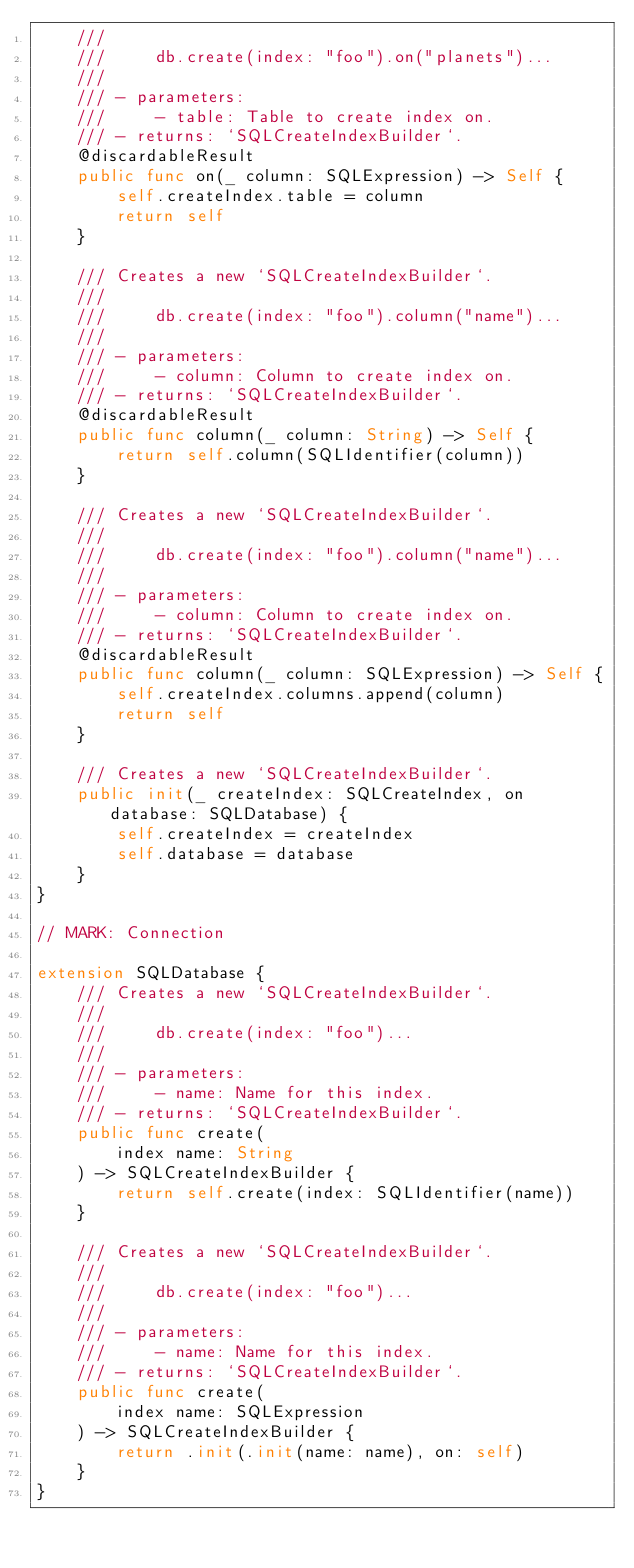<code> <loc_0><loc_0><loc_500><loc_500><_Swift_>    ///
    ///     db.create(index: "foo").on("planets")...
    ///
    /// - parameters:
    ///     - table: Table to create index on.
    /// - returns: `SQLCreateIndexBuilder`.
    @discardableResult
    public func on(_ column: SQLExpression) -> Self {
        self.createIndex.table = column
        return self
    }
    
    /// Creates a new `SQLCreateIndexBuilder`.
    ///
    ///     db.create(index: "foo").column("name")...
    ///
    /// - parameters:
    ///     - column: Column to create index on.
    /// - returns: `SQLCreateIndexBuilder`.
    @discardableResult
    public func column(_ column: String) -> Self {
        return self.column(SQLIdentifier(column))
    }
    
    /// Creates a new `SQLCreateIndexBuilder`.
    ///
    ///     db.create(index: "foo").column("name")...
    ///
    /// - parameters:
    ///     - column: Column to create index on.
    /// - returns: `SQLCreateIndexBuilder`.
    @discardableResult
    public func column(_ column: SQLExpression) -> Self {
        self.createIndex.columns.append(column)
        return self
    }
    
    /// Creates a new `SQLCreateIndexBuilder`.
    public init(_ createIndex: SQLCreateIndex, on database: SQLDatabase) {
        self.createIndex = createIndex
        self.database = database
    }
}

// MARK: Connection

extension SQLDatabase {
    /// Creates a new `SQLCreateIndexBuilder`.
    ///
    ///     db.create(index: "foo")...
    ///
    /// - parameters:
    ///     - name: Name for this index.
    /// - returns: `SQLCreateIndexBuilder`.
    public func create(
        index name: String
    ) -> SQLCreateIndexBuilder {
        return self.create(index: SQLIdentifier(name))
    }
    
    /// Creates a new `SQLCreateIndexBuilder`.
    ///
    ///     db.create(index: "foo")...
    ///
    /// - parameters:
    ///     - name: Name for this index.
    /// - returns: `SQLCreateIndexBuilder`.
    public func create(
        index name: SQLExpression
    ) -> SQLCreateIndexBuilder {
        return .init(.init(name: name), on: self)
    }
}
</code> 